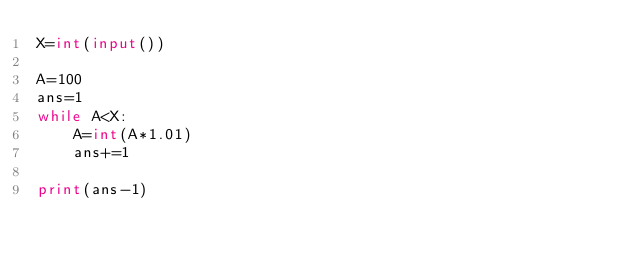Convert code to text. <code><loc_0><loc_0><loc_500><loc_500><_Python_>X=int(input())

A=100
ans=1
while A<X:
    A=int(A*1.01)
    ans+=1

print(ans-1)</code> 